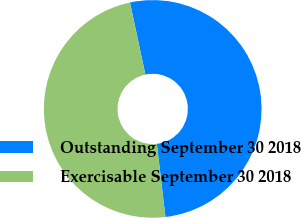Convert chart to OTSL. <chart><loc_0><loc_0><loc_500><loc_500><pie_chart><fcel>Outstanding September 30 2018<fcel>Exercisable September 30 2018<nl><fcel>51.48%<fcel>48.52%<nl></chart> 